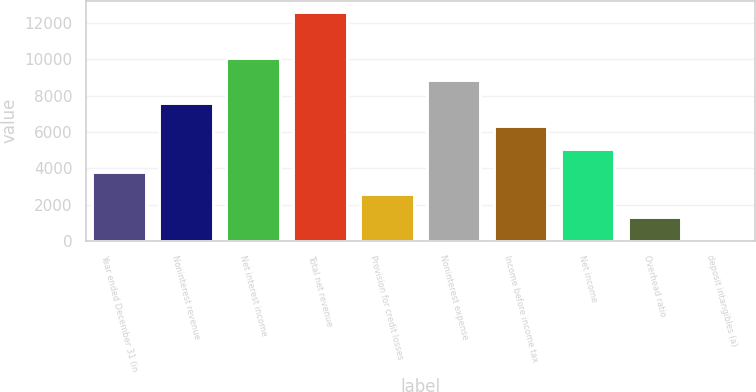Convert chart to OTSL. <chart><loc_0><loc_0><loc_500><loc_500><bar_chart><fcel>Year ended December 31 (in<fcel>Noninterest revenue<fcel>Net interest income<fcel>Total net revenue<fcel>Provision for credit losses<fcel>Noninterest expense<fcel>Income before income tax<fcel>Net income<fcel>Overhead ratio<fcel>deposit intangibles (a)<nl><fcel>3820.8<fcel>7587.6<fcel>10098.8<fcel>12610<fcel>2565.2<fcel>8843.2<fcel>6332<fcel>5076.4<fcel>1309.6<fcel>54<nl></chart> 